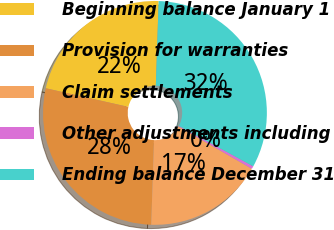Convert chart. <chart><loc_0><loc_0><loc_500><loc_500><pie_chart><fcel>Beginning balance January 1<fcel>Provision for warranties<fcel>Claim settlements<fcel>Other adjustments including<fcel>Ending balance December 31<nl><fcel>22.0%<fcel>28.0%<fcel>17.21%<fcel>0.4%<fcel>32.39%<nl></chart> 